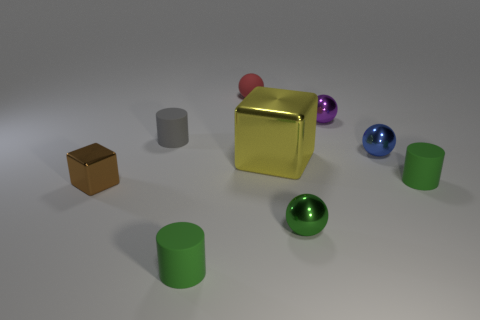In the scene, what are the colors of the spheres, and how many are there? There are four spheres in the scene. From left to right, their colors are blue, purple, metallic green, and metallic blue. 